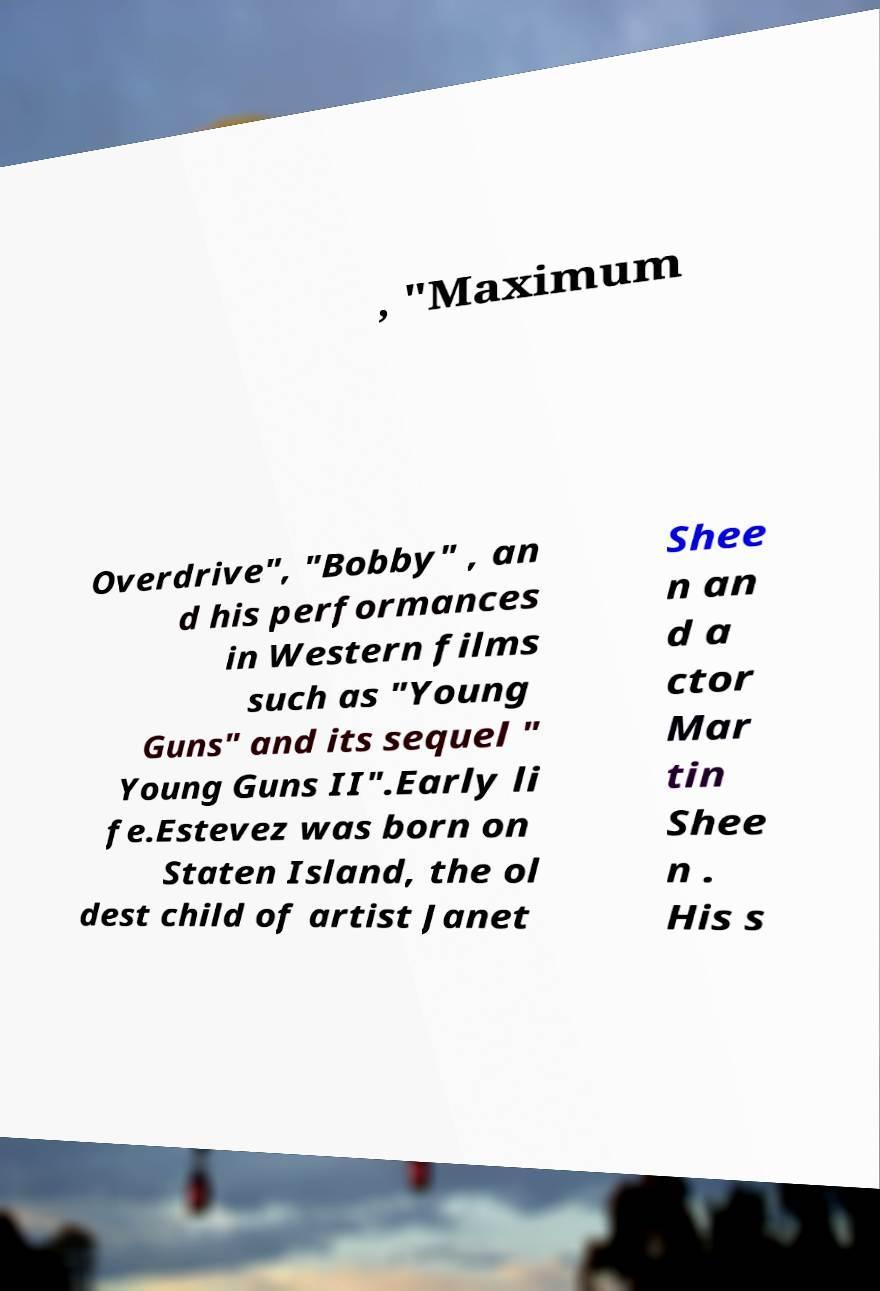Please identify and transcribe the text found in this image. , "Maximum Overdrive", "Bobby" , an d his performances in Western films such as "Young Guns" and its sequel " Young Guns II".Early li fe.Estevez was born on Staten Island, the ol dest child of artist Janet Shee n an d a ctor Mar tin Shee n . His s 